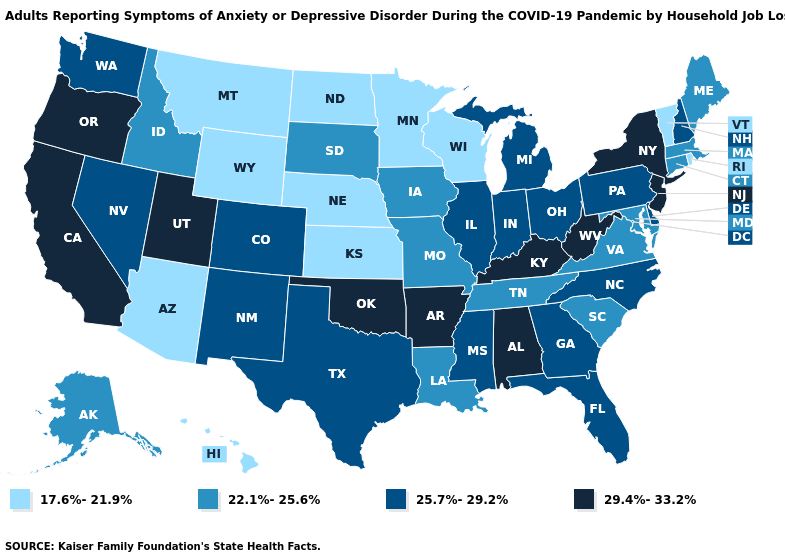How many symbols are there in the legend?
Concise answer only. 4. What is the value of Tennessee?
Keep it brief. 22.1%-25.6%. Is the legend a continuous bar?
Write a very short answer. No. Does Minnesota have the highest value in the MidWest?
Quick response, please. No. Among the states that border Oklahoma , does Missouri have the lowest value?
Quick response, please. No. Does South Carolina have the lowest value in the South?
Short answer required. Yes. Does the first symbol in the legend represent the smallest category?
Write a very short answer. Yes. Does New Hampshire have the highest value in the Northeast?
Keep it brief. No. What is the value of New Mexico?
Give a very brief answer. 25.7%-29.2%. What is the value of Rhode Island?
Concise answer only. 17.6%-21.9%. Does the map have missing data?
Give a very brief answer. No. Name the states that have a value in the range 22.1%-25.6%?
Give a very brief answer. Alaska, Connecticut, Idaho, Iowa, Louisiana, Maine, Maryland, Massachusetts, Missouri, South Carolina, South Dakota, Tennessee, Virginia. Name the states that have a value in the range 17.6%-21.9%?
Answer briefly. Arizona, Hawaii, Kansas, Minnesota, Montana, Nebraska, North Dakota, Rhode Island, Vermont, Wisconsin, Wyoming. Is the legend a continuous bar?
Give a very brief answer. No. Is the legend a continuous bar?
Quick response, please. No. 